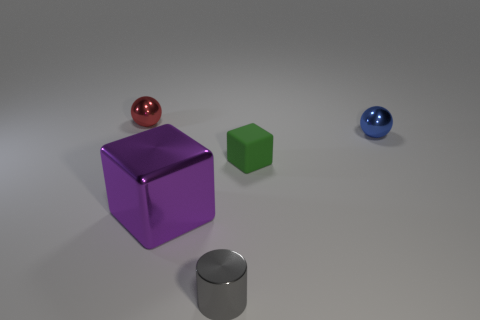Subtract all red balls. How many balls are left? 1 Subtract all blocks. How many objects are left? 3 Add 1 small yellow matte things. How many objects exist? 6 Subtract 1 spheres. How many spheres are left? 1 Subtract all tiny metallic cylinders. Subtract all tiny purple things. How many objects are left? 4 Add 2 large cubes. How many large cubes are left? 3 Add 3 gray objects. How many gray objects exist? 4 Subtract 0 gray balls. How many objects are left? 5 Subtract all yellow cylinders. Subtract all yellow spheres. How many cylinders are left? 1 